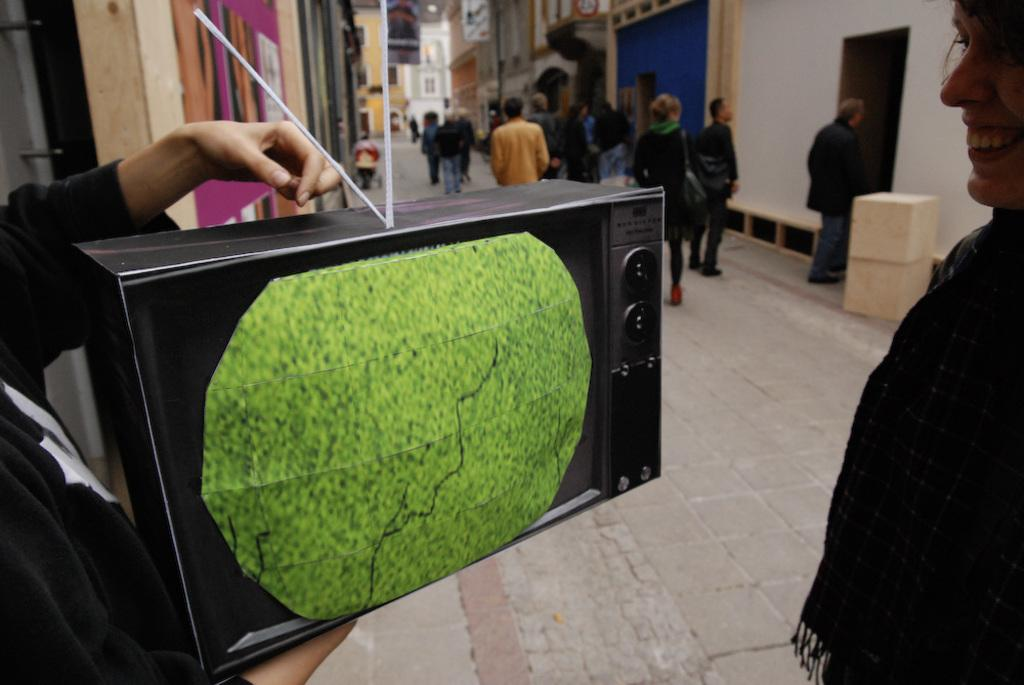What is the main object in the image? There is a screen in the image. What can be seen in the background of the image? There are buildings in the image. What other objects are present in the image? There are boxes in the image. What are the people in the image doing? There are people walking in the image. What color is the truck in the image? There is no truck present in the image. 